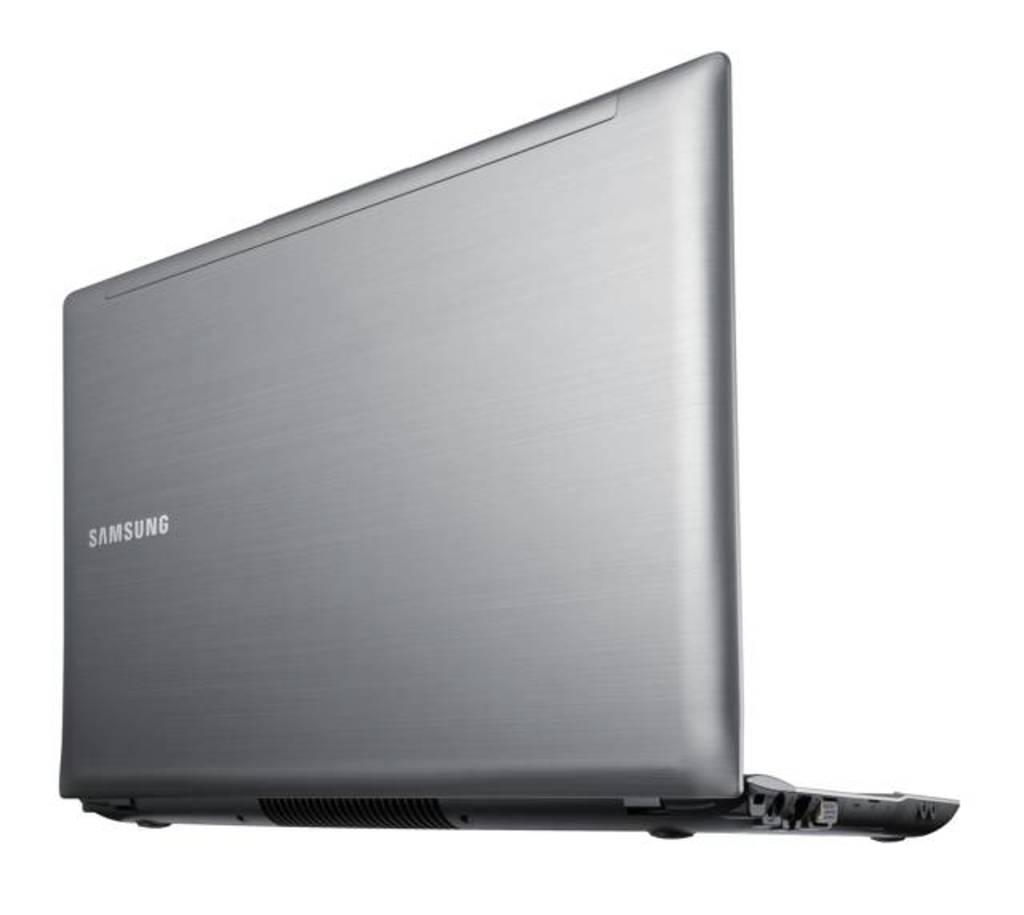What is the brand of this laptop?
Provide a succinct answer. Samsung. 